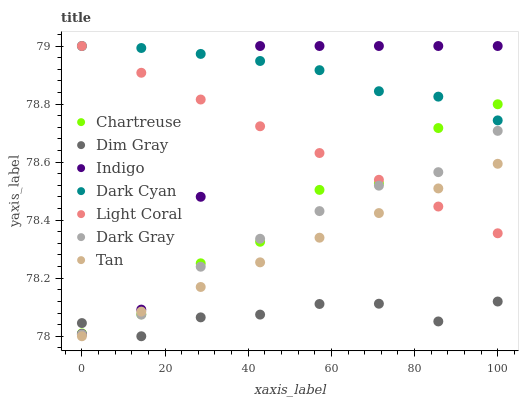Does Dim Gray have the minimum area under the curve?
Answer yes or no. Yes. Does Dark Cyan have the maximum area under the curve?
Answer yes or no. Yes. Does Indigo have the minimum area under the curve?
Answer yes or no. No. Does Indigo have the maximum area under the curve?
Answer yes or no. No. Is Light Coral the smoothest?
Answer yes or no. Yes. Is Indigo the roughest?
Answer yes or no. Yes. Is Dim Gray the smoothest?
Answer yes or no. No. Is Dim Gray the roughest?
Answer yes or no. No. Does Dim Gray have the lowest value?
Answer yes or no. Yes. Does Indigo have the lowest value?
Answer yes or no. No. Does Dark Cyan have the highest value?
Answer yes or no. Yes. Does Dim Gray have the highest value?
Answer yes or no. No. Is Dark Gray less than Dark Cyan?
Answer yes or no. Yes. Is Indigo greater than Tan?
Answer yes or no. Yes. Does Chartreuse intersect Dark Gray?
Answer yes or no. Yes. Is Chartreuse less than Dark Gray?
Answer yes or no. No. Is Chartreuse greater than Dark Gray?
Answer yes or no. No. Does Dark Gray intersect Dark Cyan?
Answer yes or no. No. 